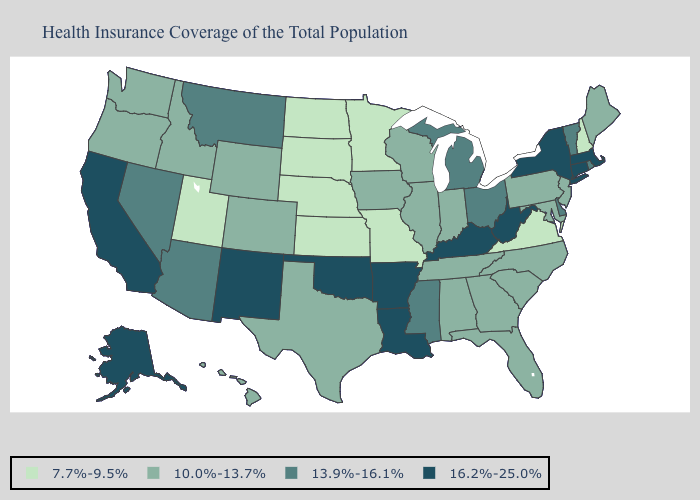What is the value of Utah?
Answer briefly. 7.7%-9.5%. Does Virginia have the lowest value in the South?
Keep it brief. Yes. Does Missouri have the lowest value in the MidWest?
Answer briefly. Yes. What is the lowest value in the USA?
Give a very brief answer. 7.7%-9.5%. What is the lowest value in the South?
Keep it brief. 7.7%-9.5%. How many symbols are there in the legend?
Write a very short answer. 4. Name the states that have a value in the range 7.7%-9.5%?
Short answer required. Kansas, Minnesota, Missouri, Nebraska, New Hampshire, North Dakota, South Dakota, Utah, Virginia. Does Connecticut have the highest value in the Northeast?
Answer briefly. Yes. Name the states that have a value in the range 7.7%-9.5%?
Concise answer only. Kansas, Minnesota, Missouri, Nebraska, New Hampshire, North Dakota, South Dakota, Utah, Virginia. What is the highest value in the USA?
Short answer required. 16.2%-25.0%. What is the highest value in the USA?
Keep it brief. 16.2%-25.0%. Which states have the highest value in the USA?
Be succinct. Alaska, Arkansas, California, Connecticut, Kentucky, Louisiana, Massachusetts, New Mexico, New York, Oklahoma, West Virginia. Name the states that have a value in the range 7.7%-9.5%?
Write a very short answer. Kansas, Minnesota, Missouri, Nebraska, New Hampshire, North Dakota, South Dakota, Utah, Virginia. Name the states that have a value in the range 16.2%-25.0%?
Answer briefly. Alaska, Arkansas, California, Connecticut, Kentucky, Louisiana, Massachusetts, New Mexico, New York, Oklahoma, West Virginia. What is the value of Connecticut?
Write a very short answer. 16.2%-25.0%. 